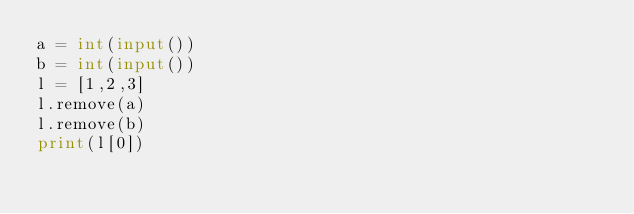<code> <loc_0><loc_0><loc_500><loc_500><_Python_>a = int(input())
b = int(input())
l = [1,2,3]
l.remove(a)
l.remove(b)
print(l[0])</code> 